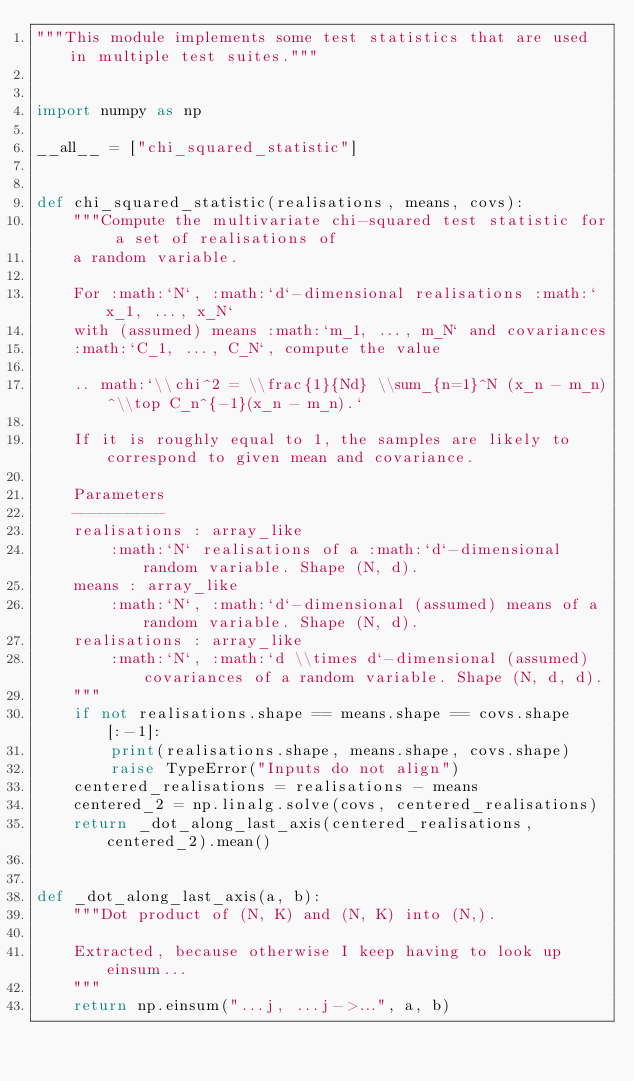<code> <loc_0><loc_0><loc_500><loc_500><_Python_>"""This module implements some test statistics that are used in multiple test suites."""


import numpy as np

__all__ = ["chi_squared_statistic"]


def chi_squared_statistic(realisations, means, covs):
    """Compute the multivariate chi-squared test statistic for a set of realisations of
    a random variable.

    For :math:`N`, :math:`d`-dimensional realisations :math:`x_1, ..., x_N`
    with (assumed) means :math:`m_1, ..., m_N` and covariances
    :math:`C_1, ..., C_N`, compute the value

    .. math:`\\chi^2 = \\frac{1}{Nd} \\sum_{n=1}^N (x_n - m_n)^\\top C_n^{-1}(x_n - m_n).`

    If it is roughly equal to 1, the samples are likely to correspond to given mean and covariance.

    Parameters
    ----------
    realisations : array_like
        :math:`N` realisations of a :math:`d`-dimensional random variable. Shape (N, d).
    means : array_like
        :math:`N`, :math:`d`-dimensional (assumed) means of a random variable. Shape (N, d).
    realisations : array_like
        :math:`N`, :math:`d \\times d`-dimensional (assumed) covariances of a random variable. Shape (N, d, d).
    """
    if not realisations.shape == means.shape == covs.shape[:-1]:
        print(realisations.shape, means.shape, covs.shape)
        raise TypeError("Inputs do not align")
    centered_realisations = realisations - means
    centered_2 = np.linalg.solve(covs, centered_realisations)
    return _dot_along_last_axis(centered_realisations, centered_2).mean()


def _dot_along_last_axis(a, b):
    """Dot product of (N, K) and (N, K) into (N,).

    Extracted, because otherwise I keep having to look up einsum...
    """
    return np.einsum("...j, ...j->...", a, b)
</code> 